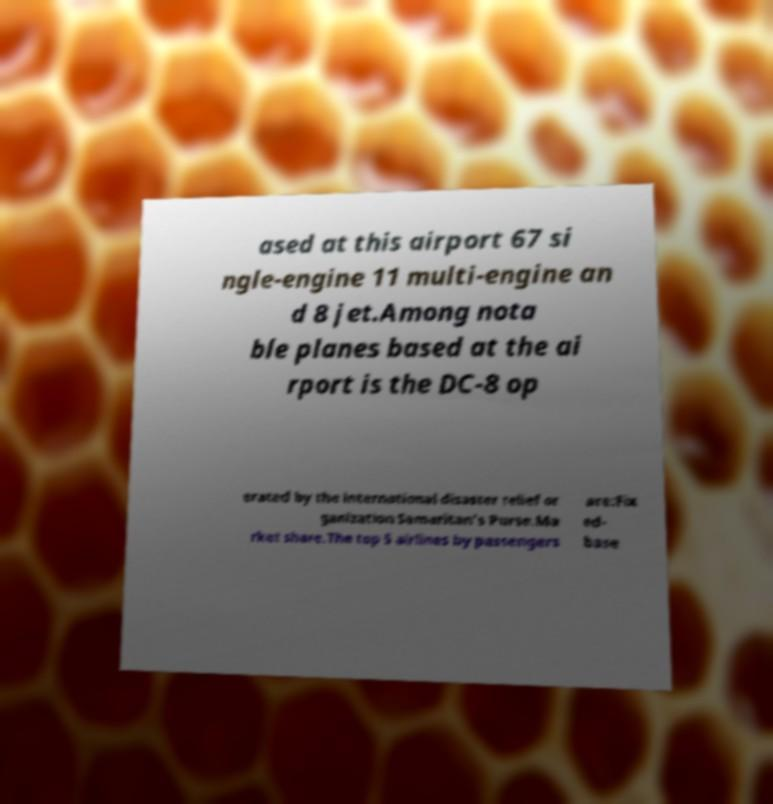I need the written content from this picture converted into text. Can you do that? ased at this airport 67 si ngle-engine 11 multi-engine an d 8 jet.Among nota ble planes based at the ai rport is the DC-8 op erated by the international disaster relief or ganization Samaritan's Purse.Ma rket share.The top 5 airlines by passengers are:Fix ed- base 